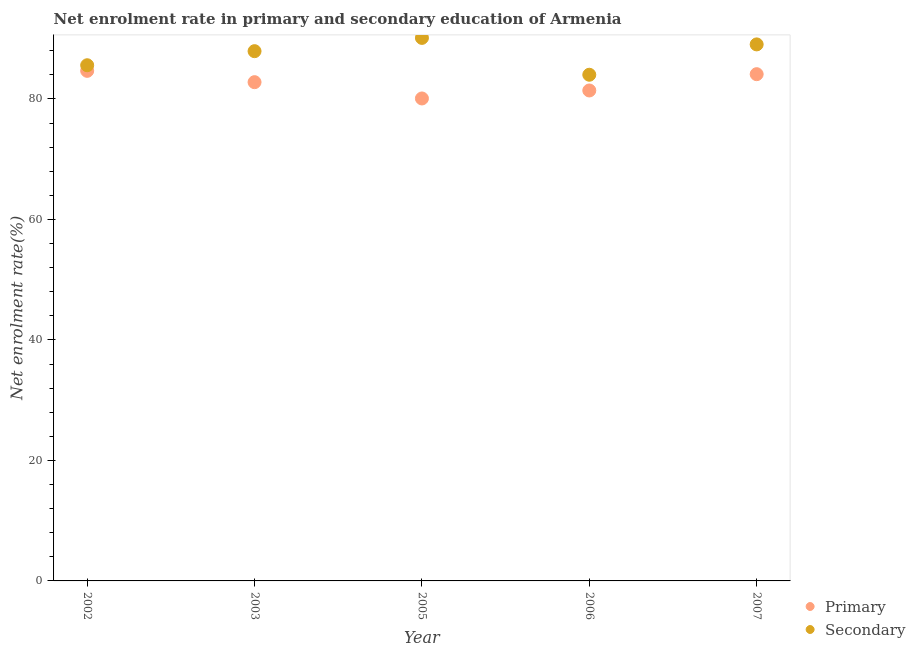How many different coloured dotlines are there?
Give a very brief answer. 2. What is the enrollment rate in primary education in 2005?
Ensure brevity in your answer.  80.09. Across all years, what is the maximum enrollment rate in secondary education?
Offer a terse response. 90.14. Across all years, what is the minimum enrollment rate in primary education?
Provide a short and direct response. 80.09. In which year was the enrollment rate in primary education minimum?
Offer a very short reply. 2005. What is the total enrollment rate in secondary education in the graph?
Your answer should be very brief. 436.77. What is the difference between the enrollment rate in secondary education in 2005 and that in 2007?
Offer a terse response. 1.08. What is the difference between the enrollment rate in primary education in 2007 and the enrollment rate in secondary education in 2006?
Your answer should be compact. 0.09. What is the average enrollment rate in secondary education per year?
Make the answer very short. 87.35. In the year 2003, what is the difference between the enrollment rate in primary education and enrollment rate in secondary education?
Keep it short and to the point. -5.15. In how many years, is the enrollment rate in secondary education greater than 84 %?
Provide a short and direct response. 5. What is the ratio of the enrollment rate in secondary education in 2002 to that in 2005?
Your answer should be very brief. 0.95. Is the difference between the enrollment rate in primary education in 2002 and 2003 greater than the difference between the enrollment rate in secondary education in 2002 and 2003?
Provide a short and direct response. Yes. What is the difference between the highest and the second highest enrollment rate in primary education?
Ensure brevity in your answer.  0.55. What is the difference between the highest and the lowest enrollment rate in secondary education?
Ensure brevity in your answer.  6.12. Is the sum of the enrollment rate in secondary education in 2005 and 2007 greater than the maximum enrollment rate in primary education across all years?
Your response must be concise. Yes. Is the enrollment rate in secondary education strictly less than the enrollment rate in primary education over the years?
Your answer should be compact. No. How many dotlines are there?
Your response must be concise. 2. How many years are there in the graph?
Your answer should be compact. 5. What is the difference between two consecutive major ticks on the Y-axis?
Offer a very short reply. 20. Does the graph contain grids?
Offer a very short reply. No. How are the legend labels stacked?
Ensure brevity in your answer.  Vertical. What is the title of the graph?
Your response must be concise. Net enrolment rate in primary and secondary education of Armenia. Does "Pregnant women" appear as one of the legend labels in the graph?
Your response must be concise. No. What is the label or title of the X-axis?
Provide a short and direct response. Year. What is the label or title of the Y-axis?
Offer a terse response. Net enrolment rate(%). What is the Net enrolment rate(%) of Primary in 2002?
Make the answer very short. 84.67. What is the Net enrolment rate(%) in Secondary in 2002?
Give a very brief answer. 85.6. What is the Net enrolment rate(%) of Primary in 2003?
Make the answer very short. 82.79. What is the Net enrolment rate(%) in Secondary in 2003?
Give a very brief answer. 87.94. What is the Net enrolment rate(%) in Primary in 2005?
Your response must be concise. 80.09. What is the Net enrolment rate(%) of Secondary in 2005?
Provide a succinct answer. 90.14. What is the Net enrolment rate(%) of Primary in 2006?
Make the answer very short. 81.41. What is the Net enrolment rate(%) of Secondary in 2006?
Offer a very short reply. 84.03. What is the Net enrolment rate(%) of Primary in 2007?
Provide a succinct answer. 84.12. What is the Net enrolment rate(%) of Secondary in 2007?
Ensure brevity in your answer.  89.06. Across all years, what is the maximum Net enrolment rate(%) of Primary?
Ensure brevity in your answer.  84.67. Across all years, what is the maximum Net enrolment rate(%) of Secondary?
Your response must be concise. 90.14. Across all years, what is the minimum Net enrolment rate(%) in Primary?
Provide a short and direct response. 80.09. Across all years, what is the minimum Net enrolment rate(%) in Secondary?
Provide a succinct answer. 84.03. What is the total Net enrolment rate(%) of Primary in the graph?
Give a very brief answer. 413.08. What is the total Net enrolment rate(%) of Secondary in the graph?
Ensure brevity in your answer.  436.77. What is the difference between the Net enrolment rate(%) in Primary in 2002 and that in 2003?
Your response must be concise. 1.88. What is the difference between the Net enrolment rate(%) in Secondary in 2002 and that in 2003?
Offer a terse response. -2.34. What is the difference between the Net enrolment rate(%) of Primary in 2002 and that in 2005?
Keep it short and to the point. 4.58. What is the difference between the Net enrolment rate(%) in Secondary in 2002 and that in 2005?
Offer a very short reply. -4.54. What is the difference between the Net enrolment rate(%) of Primary in 2002 and that in 2006?
Your response must be concise. 3.26. What is the difference between the Net enrolment rate(%) of Secondary in 2002 and that in 2006?
Provide a short and direct response. 1.58. What is the difference between the Net enrolment rate(%) of Primary in 2002 and that in 2007?
Your answer should be compact. 0.55. What is the difference between the Net enrolment rate(%) in Secondary in 2002 and that in 2007?
Your answer should be compact. -3.46. What is the difference between the Net enrolment rate(%) in Primary in 2003 and that in 2005?
Make the answer very short. 2.7. What is the difference between the Net enrolment rate(%) of Secondary in 2003 and that in 2005?
Offer a terse response. -2.2. What is the difference between the Net enrolment rate(%) of Primary in 2003 and that in 2006?
Keep it short and to the point. 1.38. What is the difference between the Net enrolment rate(%) in Secondary in 2003 and that in 2006?
Provide a succinct answer. 3.91. What is the difference between the Net enrolment rate(%) in Primary in 2003 and that in 2007?
Keep it short and to the point. -1.33. What is the difference between the Net enrolment rate(%) in Secondary in 2003 and that in 2007?
Your response must be concise. -1.12. What is the difference between the Net enrolment rate(%) of Primary in 2005 and that in 2006?
Your response must be concise. -1.33. What is the difference between the Net enrolment rate(%) in Secondary in 2005 and that in 2006?
Offer a very short reply. 6.12. What is the difference between the Net enrolment rate(%) of Primary in 2005 and that in 2007?
Provide a short and direct response. -4.03. What is the difference between the Net enrolment rate(%) of Secondary in 2005 and that in 2007?
Your answer should be very brief. 1.08. What is the difference between the Net enrolment rate(%) in Primary in 2006 and that in 2007?
Offer a very short reply. -2.71. What is the difference between the Net enrolment rate(%) of Secondary in 2006 and that in 2007?
Offer a very short reply. -5.04. What is the difference between the Net enrolment rate(%) in Primary in 2002 and the Net enrolment rate(%) in Secondary in 2003?
Give a very brief answer. -3.27. What is the difference between the Net enrolment rate(%) of Primary in 2002 and the Net enrolment rate(%) of Secondary in 2005?
Give a very brief answer. -5.47. What is the difference between the Net enrolment rate(%) in Primary in 2002 and the Net enrolment rate(%) in Secondary in 2006?
Keep it short and to the point. 0.65. What is the difference between the Net enrolment rate(%) of Primary in 2002 and the Net enrolment rate(%) of Secondary in 2007?
Offer a very short reply. -4.39. What is the difference between the Net enrolment rate(%) of Primary in 2003 and the Net enrolment rate(%) of Secondary in 2005?
Ensure brevity in your answer.  -7.35. What is the difference between the Net enrolment rate(%) of Primary in 2003 and the Net enrolment rate(%) of Secondary in 2006?
Your answer should be very brief. -1.23. What is the difference between the Net enrolment rate(%) in Primary in 2003 and the Net enrolment rate(%) in Secondary in 2007?
Ensure brevity in your answer.  -6.27. What is the difference between the Net enrolment rate(%) of Primary in 2005 and the Net enrolment rate(%) of Secondary in 2006?
Your answer should be compact. -3.94. What is the difference between the Net enrolment rate(%) of Primary in 2005 and the Net enrolment rate(%) of Secondary in 2007?
Your answer should be compact. -8.97. What is the difference between the Net enrolment rate(%) of Primary in 2006 and the Net enrolment rate(%) of Secondary in 2007?
Ensure brevity in your answer.  -7.65. What is the average Net enrolment rate(%) of Primary per year?
Give a very brief answer. 82.62. What is the average Net enrolment rate(%) of Secondary per year?
Your answer should be very brief. 87.35. In the year 2002, what is the difference between the Net enrolment rate(%) in Primary and Net enrolment rate(%) in Secondary?
Offer a very short reply. -0.93. In the year 2003, what is the difference between the Net enrolment rate(%) of Primary and Net enrolment rate(%) of Secondary?
Ensure brevity in your answer.  -5.15. In the year 2005, what is the difference between the Net enrolment rate(%) of Primary and Net enrolment rate(%) of Secondary?
Provide a short and direct response. -10.05. In the year 2006, what is the difference between the Net enrolment rate(%) in Primary and Net enrolment rate(%) in Secondary?
Ensure brevity in your answer.  -2.61. In the year 2007, what is the difference between the Net enrolment rate(%) of Primary and Net enrolment rate(%) of Secondary?
Your answer should be compact. -4.94. What is the ratio of the Net enrolment rate(%) in Primary in 2002 to that in 2003?
Offer a terse response. 1.02. What is the ratio of the Net enrolment rate(%) in Secondary in 2002 to that in 2003?
Your answer should be compact. 0.97. What is the ratio of the Net enrolment rate(%) of Primary in 2002 to that in 2005?
Keep it short and to the point. 1.06. What is the ratio of the Net enrolment rate(%) of Secondary in 2002 to that in 2005?
Your answer should be very brief. 0.95. What is the ratio of the Net enrolment rate(%) of Primary in 2002 to that in 2006?
Your response must be concise. 1.04. What is the ratio of the Net enrolment rate(%) of Secondary in 2002 to that in 2006?
Your answer should be compact. 1.02. What is the ratio of the Net enrolment rate(%) of Primary in 2002 to that in 2007?
Provide a short and direct response. 1.01. What is the ratio of the Net enrolment rate(%) of Secondary in 2002 to that in 2007?
Offer a terse response. 0.96. What is the ratio of the Net enrolment rate(%) in Primary in 2003 to that in 2005?
Provide a short and direct response. 1.03. What is the ratio of the Net enrolment rate(%) of Secondary in 2003 to that in 2005?
Offer a very short reply. 0.98. What is the ratio of the Net enrolment rate(%) of Primary in 2003 to that in 2006?
Offer a terse response. 1.02. What is the ratio of the Net enrolment rate(%) in Secondary in 2003 to that in 2006?
Keep it short and to the point. 1.05. What is the ratio of the Net enrolment rate(%) of Primary in 2003 to that in 2007?
Your answer should be compact. 0.98. What is the ratio of the Net enrolment rate(%) of Secondary in 2003 to that in 2007?
Your answer should be very brief. 0.99. What is the ratio of the Net enrolment rate(%) in Primary in 2005 to that in 2006?
Ensure brevity in your answer.  0.98. What is the ratio of the Net enrolment rate(%) of Secondary in 2005 to that in 2006?
Make the answer very short. 1.07. What is the ratio of the Net enrolment rate(%) in Primary in 2005 to that in 2007?
Your answer should be very brief. 0.95. What is the ratio of the Net enrolment rate(%) in Secondary in 2005 to that in 2007?
Give a very brief answer. 1.01. What is the ratio of the Net enrolment rate(%) of Primary in 2006 to that in 2007?
Provide a short and direct response. 0.97. What is the ratio of the Net enrolment rate(%) of Secondary in 2006 to that in 2007?
Keep it short and to the point. 0.94. What is the difference between the highest and the second highest Net enrolment rate(%) of Primary?
Ensure brevity in your answer.  0.55. What is the difference between the highest and the second highest Net enrolment rate(%) in Secondary?
Make the answer very short. 1.08. What is the difference between the highest and the lowest Net enrolment rate(%) in Primary?
Provide a succinct answer. 4.58. What is the difference between the highest and the lowest Net enrolment rate(%) of Secondary?
Keep it short and to the point. 6.12. 